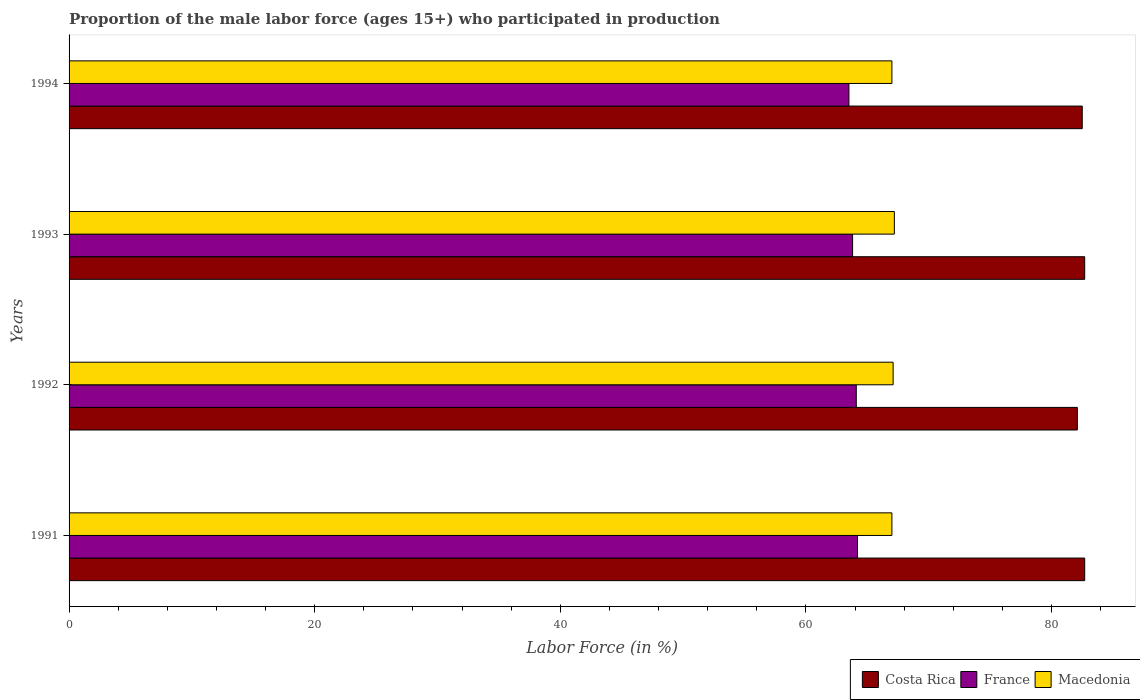How many groups of bars are there?
Offer a terse response. 4. Are the number of bars on each tick of the Y-axis equal?
Keep it short and to the point. Yes. How many bars are there on the 1st tick from the top?
Ensure brevity in your answer.  3. How many bars are there on the 3rd tick from the bottom?
Your answer should be compact. 3. In how many cases, is the number of bars for a given year not equal to the number of legend labels?
Make the answer very short. 0. What is the proportion of the male labor force who participated in production in France in 1991?
Give a very brief answer. 64.2. Across all years, what is the maximum proportion of the male labor force who participated in production in Costa Rica?
Ensure brevity in your answer.  82.7. Across all years, what is the minimum proportion of the male labor force who participated in production in France?
Provide a succinct answer. 63.5. In which year was the proportion of the male labor force who participated in production in Costa Rica maximum?
Give a very brief answer. 1991. In which year was the proportion of the male labor force who participated in production in France minimum?
Your response must be concise. 1994. What is the total proportion of the male labor force who participated in production in France in the graph?
Keep it short and to the point. 255.6. What is the difference between the proportion of the male labor force who participated in production in Macedonia in 1991 and that in 1992?
Make the answer very short. -0.1. What is the difference between the proportion of the male labor force who participated in production in France in 1993 and the proportion of the male labor force who participated in production in Costa Rica in 1992?
Make the answer very short. -18.3. What is the average proportion of the male labor force who participated in production in Costa Rica per year?
Your response must be concise. 82.5. What is the ratio of the proportion of the male labor force who participated in production in France in 1991 to that in 1994?
Ensure brevity in your answer.  1.01. Is the difference between the proportion of the male labor force who participated in production in Macedonia in 1991 and 1994 greater than the difference between the proportion of the male labor force who participated in production in France in 1991 and 1994?
Ensure brevity in your answer.  No. What is the difference between the highest and the lowest proportion of the male labor force who participated in production in Costa Rica?
Ensure brevity in your answer.  0.6. In how many years, is the proportion of the male labor force who participated in production in Macedonia greater than the average proportion of the male labor force who participated in production in Macedonia taken over all years?
Ensure brevity in your answer.  2. Is the sum of the proportion of the male labor force who participated in production in Costa Rica in 1992 and 1993 greater than the maximum proportion of the male labor force who participated in production in France across all years?
Keep it short and to the point. Yes. What does the 1st bar from the top in 1993 represents?
Keep it short and to the point. Macedonia. Is it the case that in every year, the sum of the proportion of the male labor force who participated in production in Costa Rica and proportion of the male labor force who participated in production in Macedonia is greater than the proportion of the male labor force who participated in production in France?
Ensure brevity in your answer.  Yes. What is the difference between two consecutive major ticks on the X-axis?
Your answer should be compact. 20. Does the graph contain grids?
Keep it short and to the point. No. Where does the legend appear in the graph?
Offer a very short reply. Bottom right. What is the title of the graph?
Provide a short and direct response. Proportion of the male labor force (ages 15+) who participated in production. Does "Seychelles" appear as one of the legend labels in the graph?
Ensure brevity in your answer.  No. What is the label or title of the Y-axis?
Provide a succinct answer. Years. What is the Labor Force (in %) in Costa Rica in 1991?
Give a very brief answer. 82.7. What is the Labor Force (in %) in France in 1991?
Provide a short and direct response. 64.2. What is the Labor Force (in %) of Costa Rica in 1992?
Provide a succinct answer. 82.1. What is the Labor Force (in %) in France in 1992?
Your answer should be very brief. 64.1. What is the Labor Force (in %) of Macedonia in 1992?
Ensure brevity in your answer.  67.1. What is the Labor Force (in %) of Costa Rica in 1993?
Your answer should be very brief. 82.7. What is the Labor Force (in %) in France in 1993?
Provide a succinct answer. 63.8. What is the Labor Force (in %) of Macedonia in 1993?
Your response must be concise. 67.2. What is the Labor Force (in %) of Costa Rica in 1994?
Provide a short and direct response. 82.5. What is the Labor Force (in %) in France in 1994?
Ensure brevity in your answer.  63.5. What is the Labor Force (in %) in Macedonia in 1994?
Offer a very short reply. 67. Across all years, what is the maximum Labor Force (in %) of Costa Rica?
Make the answer very short. 82.7. Across all years, what is the maximum Labor Force (in %) of France?
Your answer should be very brief. 64.2. Across all years, what is the maximum Labor Force (in %) in Macedonia?
Offer a very short reply. 67.2. Across all years, what is the minimum Labor Force (in %) in Costa Rica?
Keep it short and to the point. 82.1. Across all years, what is the minimum Labor Force (in %) in France?
Your answer should be compact. 63.5. What is the total Labor Force (in %) in Costa Rica in the graph?
Your response must be concise. 330. What is the total Labor Force (in %) of France in the graph?
Keep it short and to the point. 255.6. What is the total Labor Force (in %) in Macedonia in the graph?
Your answer should be compact. 268.3. What is the difference between the Labor Force (in %) of Costa Rica in 1991 and that in 1992?
Make the answer very short. 0.6. What is the difference between the Labor Force (in %) of Costa Rica in 1991 and that in 1993?
Keep it short and to the point. 0. What is the difference between the Labor Force (in %) of France in 1991 and that in 1993?
Ensure brevity in your answer.  0.4. What is the difference between the Labor Force (in %) in Costa Rica in 1991 and that in 1994?
Make the answer very short. 0.2. What is the difference between the Labor Force (in %) of Costa Rica in 1992 and that in 1993?
Keep it short and to the point. -0.6. What is the difference between the Labor Force (in %) of France in 1992 and that in 1993?
Your answer should be very brief. 0.3. What is the difference between the Labor Force (in %) in Costa Rica in 1992 and that in 1994?
Provide a succinct answer. -0.4. What is the difference between the Labor Force (in %) of France in 1992 and that in 1994?
Give a very brief answer. 0.6. What is the difference between the Labor Force (in %) in Costa Rica in 1993 and that in 1994?
Offer a very short reply. 0.2. What is the difference between the Labor Force (in %) of Costa Rica in 1991 and the Labor Force (in %) of France in 1992?
Your answer should be very brief. 18.6. What is the difference between the Labor Force (in %) of Costa Rica in 1991 and the Labor Force (in %) of Macedonia in 1992?
Make the answer very short. 15.6. What is the difference between the Labor Force (in %) of Costa Rica in 1991 and the Labor Force (in %) of Macedonia in 1993?
Provide a succinct answer. 15.5. What is the difference between the Labor Force (in %) in France in 1991 and the Labor Force (in %) in Macedonia in 1993?
Offer a terse response. -3. What is the difference between the Labor Force (in %) of Costa Rica in 1991 and the Labor Force (in %) of France in 1994?
Provide a short and direct response. 19.2. What is the difference between the Labor Force (in %) in Costa Rica in 1991 and the Labor Force (in %) in Macedonia in 1994?
Offer a terse response. 15.7. What is the difference between the Labor Force (in %) of France in 1992 and the Labor Force (in %) of Macedonia in 1993?
Offer a very short reply. -3.1. What is the difference between the Labor Force (in %) in Costa Rica in 1992 and the Labor Force (in %) in France in 1994?
Offer a terse response. 18.6. What is the difference between the Labor Force (in %) of France in 1992 and the Labor Force (in %) of Macedonia in 1994?
Your answer should be very brief. -2.9. What is the difference between the Labor Force (in %) in Costa Rica in 1993 and the Labor Force (in %) in France in 1994?
Make the answer very short. 19.2. What is the average Labor Force (in %) of Costa Rica per year?
Provide a succinct answer. 82.5. What is the average Labor Force (in %) in France per year?
Your response must be concise. 63.9. What is the average Labor Force (in %) in Macedonia per year?
Your answer should be compact. 67.08. In the year 1991, what is the difference between the Labor Force (in %) of Costa Rica and Labor Force (in %) of France?
Keep it short and to the point. 18.5. In the year 1991, what is the difference between the Labor Force (in %) of France and Labor Force (in %) of Macedonia?
Your answer should be compact. -2.8. In the year 1994, what is the difference between the Labor Force (in %) in Costa Rica and Labor Force (in %) in Macedonia?
Offer a terse response. 15.5. What is the ratio of the Labor Force (in %) of Costa Rica in 1991 to that in 1992?
Keep it short and to the point. 1.01. What is the ratio of the Labor Force (in %) of Macedonia in 1991 to that in 1992?
Offer a terse response. 1. What is the ratio of the Labor Force (in %) in Costa Rica in 1991 to that in 1993?
Keep it short and to the point. 1. What is the ratio of the Labor Force (in %) in Macedonia in 1991 to that in 1993?
Your answer should be compact. 1. What is the ratio of the Labor Force (in %) in Costa Rica in 1991 to that in 1994?
Make the answer very short. 1. What is the ratio of the Labor Force (in %) of France in 1991 to that in 1994?
Ensure brevity in your answer.  1.01. What is the ratio of the Labor Force (in %) in France in 1992 to that in 1993?
Your answer should be very brief. 1. What is the ratio of the Labor Force (in %) of Macedonia in 1992 to that in 1993?
Offer a terse response. 1. What is the ratio of the Labor Force (in %) of France in 1992 to that in 1994?
Offer a very short reply. 1.01. What is the ratio of the Labor Force (in %) in Macedonia in 1992 to that in 1994?
Offer a terse response. 1. What is the ratio of the Labor Force (in %) of Costa Rica in 1993 to that in 1994?
Give a very brief answer. 1. What is the ratio of the Labor Force (in %) of France in 1993 to that in 1994?
Offer a very short reply. 1. What is the ratio of the Labor Force (in %) of Macedonia in 1993 to that in 1994?
Offer a very short reply. 1. What is the difference between the highest and the lowest Labor Force (in %) in France?
Provide a succinct answer. 0.7. 